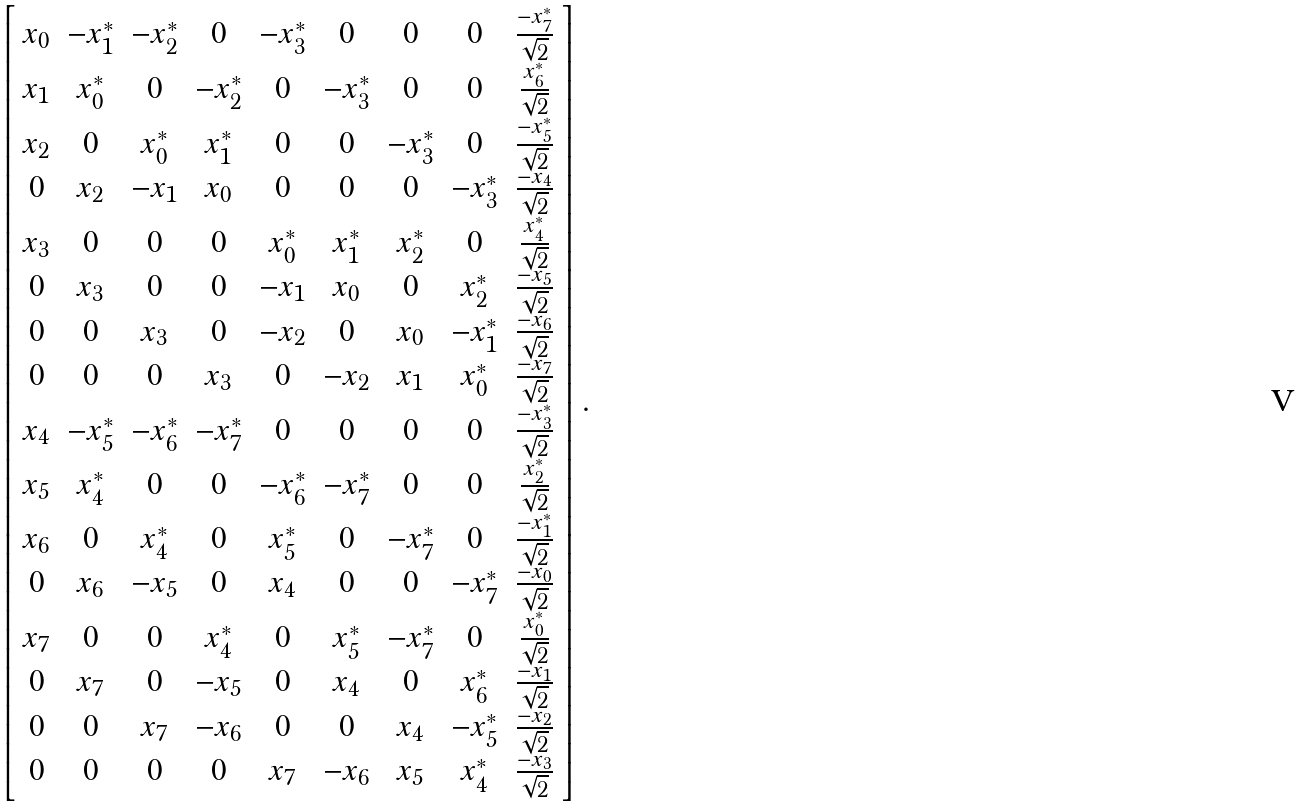Convert formula to latex. <formula><loc_0><loc_0><loc_500><loc_500>\left [ \begin{array} { c c c c c c c c c } x _ { 0 } & - x _ { 1 } ^ { * } & - x _ { 2 } ^ { * } & 0 & - x _ { 3 } ^ { * } & 0 & 0 & 0 & \frac { - x _ { 7 } ^ { * } } { \sqrt { 2 } } \\ x _ { 1 } & x _ { 0 } ^ { * } & 0 & - x _ { 2 } ^ { * } & 0 & - x _ { 3 } ^ { * } & 0 & 0 & \frac { x _ { 6 } ^ { * } } { \sqrt { 2 } } \\ x _ { 2 } & 0 & x _ { 0 } ^ { * } & x _ { 1 } ^ { * } & 0 & 0 & - x _ { 3 } ^ { * } & 0 & \frac { - x _ { 5 } ^ { * } } { \sqrt { 2 } } \\ 0 & x _ { 2 } & - x _ { 1 } & x _ { 0 } & 0 & 0 & 0 & - x _ { 3 } ^ { * } & \frac { - x _ { 4 } } { \sqrt { 2 } } \\ x _ { 3 } & 0 & 0 & 0 & x _ { 0 } ^ { * } & x _ { 1 } ^ { * } & x _ { 2 } ^ { * } & 0 & \frac { x _ { 4 } ^ { * } } { \sqrt { 2 } } \\ 0 & x _ { 3 } & 0 & 0 & - x _ { 1 } & x _ { 0 } & 0 & x _ { 2 } ^ { * } & \frac { - x _ { 5 } } { \sqrt { 2 } } \\ 0 & 0 & x _ { 3 } & 0 & - x _ { 2 } & 0 & x _ { 0 } & - x _ { 1 } ^ { * } & \frac { - x _ { 6 } } { \sqrt { 2 } } \\ 0 & 0 & 0 & x _ { 3 } & 0 & - x _ { 2 } & x _ { 1 } & x _ { 0 } ^ { * } & \frac { - x _ { 7 } } { \sqrt { 2 } } \\ x _ { 4 } & - x _ { 5 } ^ { * } & - x _ { 6 } ^ { * } & - x _ { 7 } ^ { * } & 0 & 0 & 0 & 0 & \frac { - x _ { 3 } ^ { * } } { \sqrt { 2 } } \\ x _ { 5 } & x _ { 4 } ^ { * } & 0 & 0 & - x _ { 6 } ^ { * } & - x _ { 7 } ^ { * } & 0 & 0 & \frac { x _ { 2 } ^ { * } } { \sqrt { 2 } } \\ x _ { 6 } & 0 & x _ { 4 } ^ { * } & 0 & x _ { 5 } ^ { * } & 0 & - x _ { 7 } ^ { * } & 0 & \frac { - x _ { 1 } ^ { * } } { \sqrt { 2 } } \\ 0 & x _ { 6 } & - x _ { 5 } & 0 & x _ { 4 } & 0 & 0 & - x _ { 7 } ^ { * } & \frac { - x _ { 0 } } { \sqrt { 2 } } \\ x _ { 7 } & 0 & 0 & x _ { 4 } ^ { * } & 0 & x _ { 5 } ^ { * } & - x _ { 7 } ^ { * } & 0 & \frac { x _ { 0 } ^ { * } } { \sqrt { 2 } } \\ 0 & x _ { 7 } & 0 & - x _ { 5 } & 0 & x _ { 4 } & 0 & x _ { 6 } ^ { * } & \frac { - x _ { 1 } } { \sqrt { 2 } } \\ 0 & 0 & x _ { 7 } & - x _ { 6 } & 0 & 0 & x _ { 4 } & - x _ { 5 } ^ { * } & \frac { - x _ { 2 } } { \sqrt { 2 } } \\ 0 & 0 & 0 & 0 & x _ { 7 } & - x _ { 6 } & x _ { 5 } & x _ { 4 } ^ { * } & \frac { - x _ { 3 } } { \sqrt { 2 } } \\ \end{array} \right ] .</formula> 